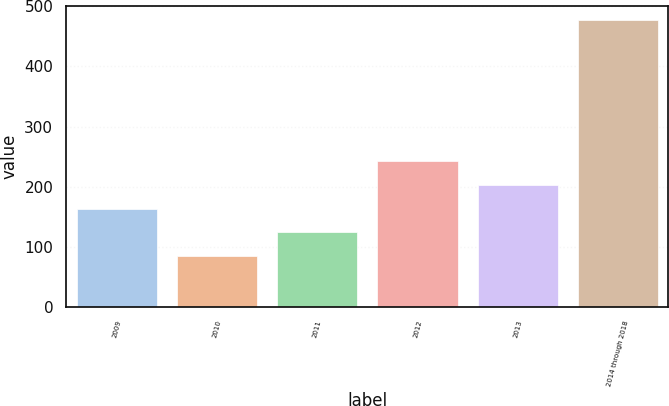Convert chart to OTSL. <chart><loc_0><loc_0><loc_500><loc_500><bar_chart><fcel>2009<fcel>2010<fcel>2011<fcel>2012<fcel>2013<fcel>2014 through 2018<nl><fcel>163.4<fcel>85<fcel>124.2<fcel>241.8<fcel>202.6<fcel>477<nl></chart> 